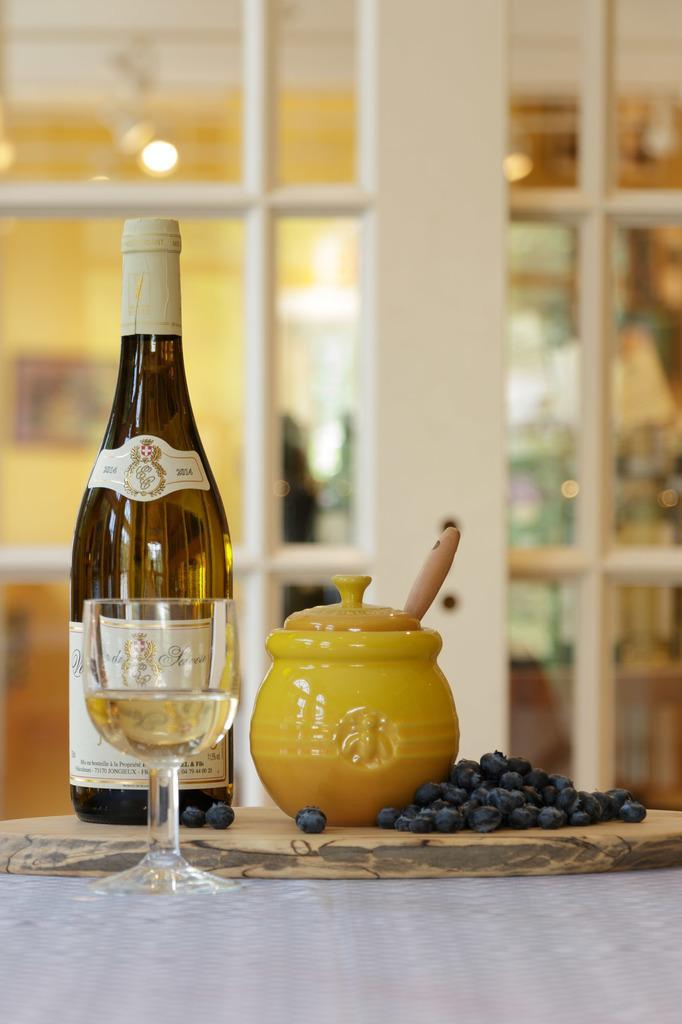Could you give a brief overview of what you see in this image? In this image we can see a alcohol bottle and we can see a glass of drink, on the right side there are some fruits and bowl, in the background we can see a glass and also we can see a light here. 